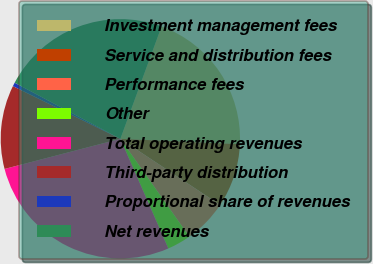<chart> <loc_0><loc_0><loc_500><loc_500><pie_chart><fcel>Investment management fees<fcel>Service and distribution fees<fcel>Performance fees<fcel>Other<fcel>Total operating revenues<fcel>Third-party distribution<fcel>Proportional share of revenues<fcel>Net revenues<nl><fcel>20.12%<fcel>8.61%<fcel>5.91%<fcel>3.21%<fcel>27.51%<fcel>11.31%<fcel>0.51%<fcel>22.83%<nl></chart> 